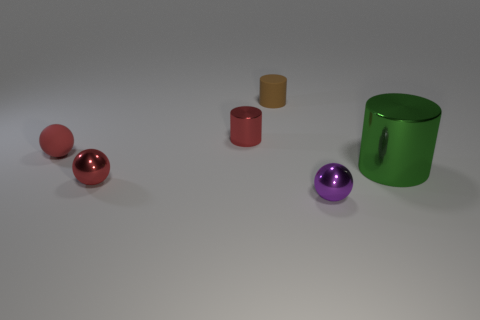What number of objects are small red shiny cylinders or small rubber cylinders?
Provide a succinct answer. 2. Are there any large red metal cylinders?
Offer a very short reply. No. What material is the cylinder behind the small cylinder in front of the small rubber object behind the tiny red matte ball?
Offer a very short reply. Rubber. Is the number of brown matte things that are behind the tiny purple metal ball less than the number of small gray metallic balls?
Provide a short and direct response. No. There is a purple ball that is the same size as the red matte object; what material is it?
Give a very brief answer. Metal. What size is the shiny object that is both right of the tiny brown rubber cylinder and behind the purple metallic sphere?
Offer a terse response. Large. What size is the matte object that is the same shape as the big green shiny object?
Give a very brief answer. Small. What number of things are small matte cylinders or small spheres in front of the green metal object?
Provide a short and direct response. 3. What shape is the small brown thing?
Keep it short and to the point. Cylinder. There is a tiny red metallic thing behind the big metallic object that is in front of the small red shiny cylinder; what is its shape?
Provide a short and direct response. Cylinder. 